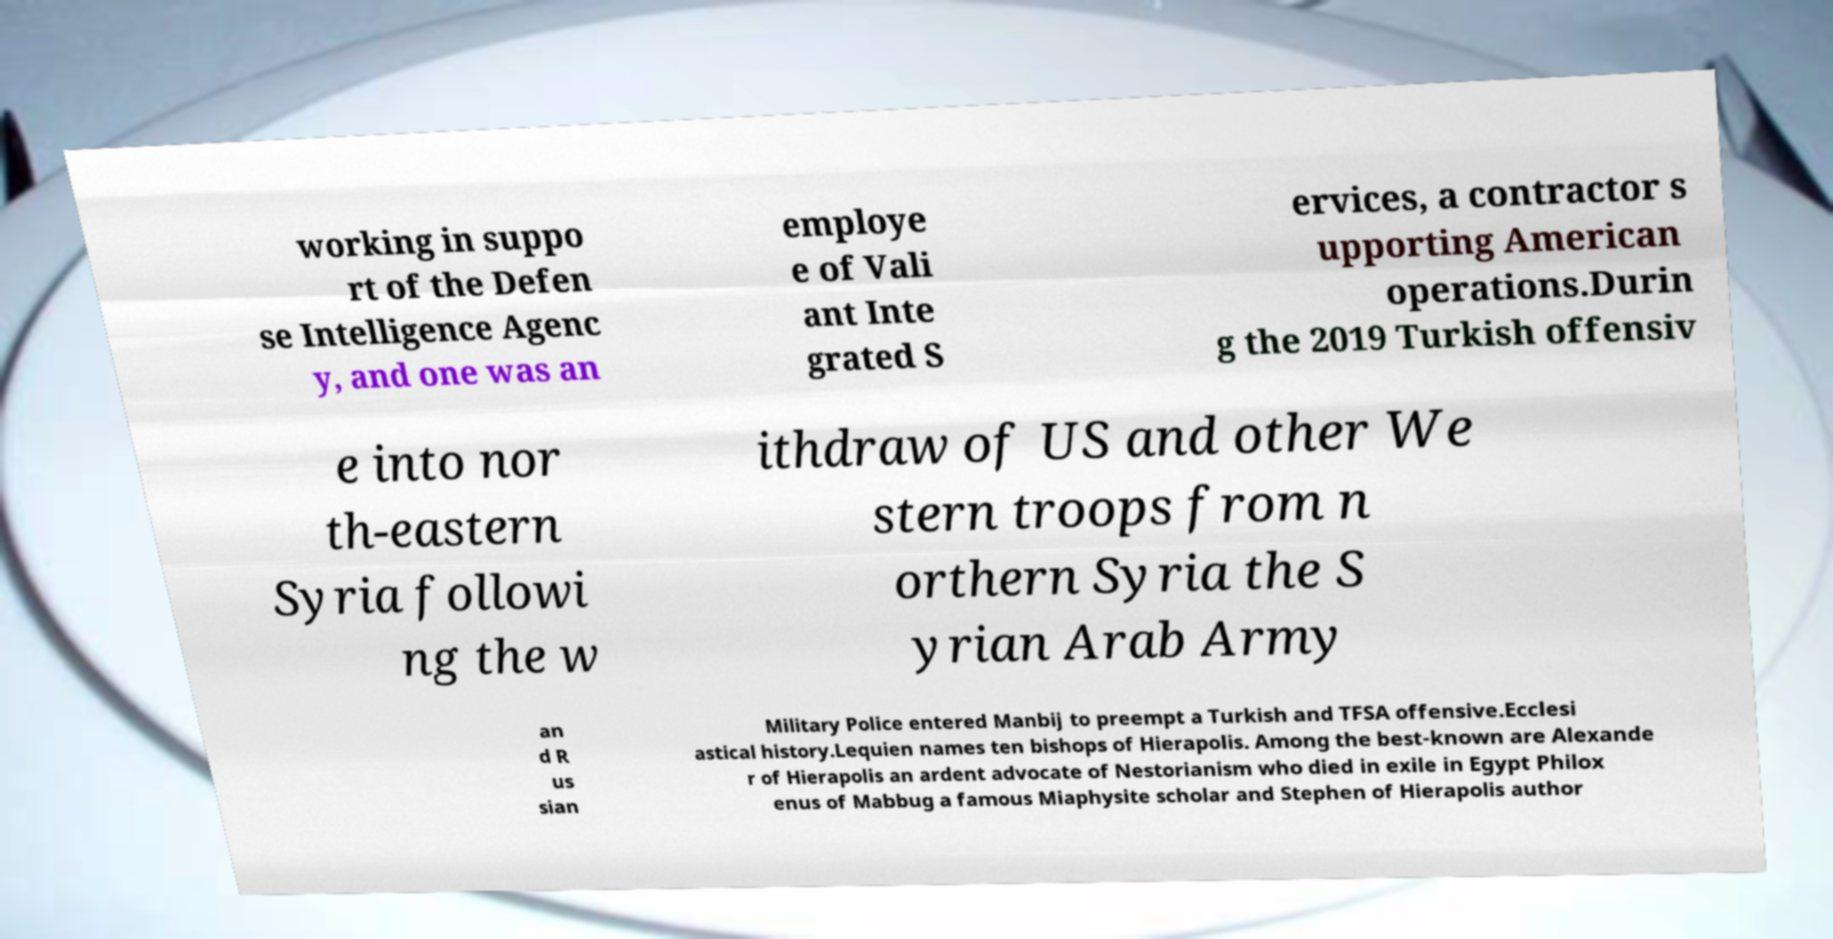For documentation purposes, I need the text within this image transcribed. Could you provide that? working in suppo rt of the Defen se Intelligence Agenc y, and one was an employe e of Vali ant Inte grated S ervices, a contractor s upporting American operations.Durin g the 2019 Turkish offensiv e into nor th-eastern Syria followi ng the w ithdraw of US and other We stern troops from n orthern Syria the S yrian Arab Army an d R us sian Military Police entered Manbij to preempt a Turkish and TFSA offensive.Ecclesi astical history.Lequien names ten bishops of Hierapolis. Among the best-known are Alexande r of Hierapolis an ardent advocate of Nestorianism who died in exile in Egypt Philox enus of Mabbug a famous Miaphysite scholar and Stephen of Hierapolis author 